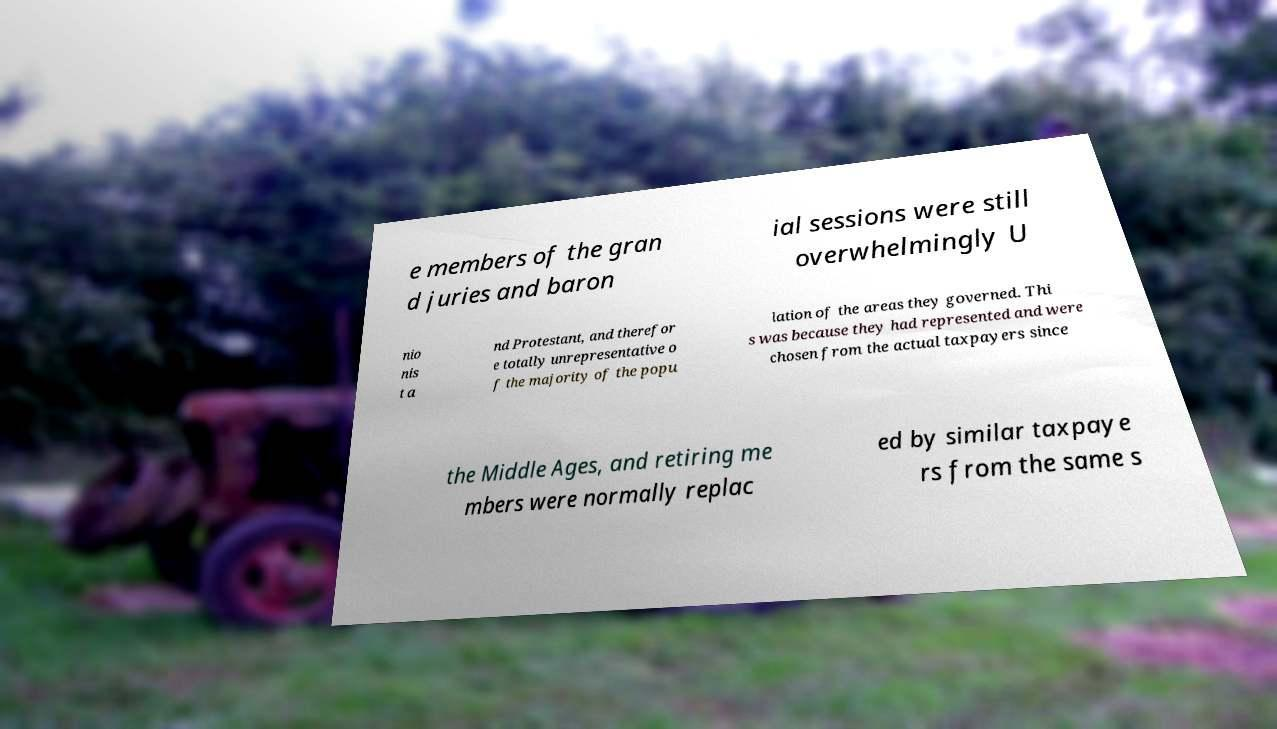I need the written content from this picture converted into text. Can you do that? e members of the gran d juries and baron ial sessions were still overwhelmingly U nio nis t a nd Protestant, and therefor e totally unrepresentative o f the majority of the popu lation of the areas they governed. Thi s was because they had represented and were chosen from the actual taxpayers since the Middle Ages, and retiring me mbers were normally replac ed by similar taxpaye rs from the same s 